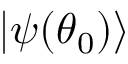<formula> <loc_0><loc_0><loc_500><loc_500>{ | { \psi ( { \theta } _ { 0 } ) } \rangle }</formula> 